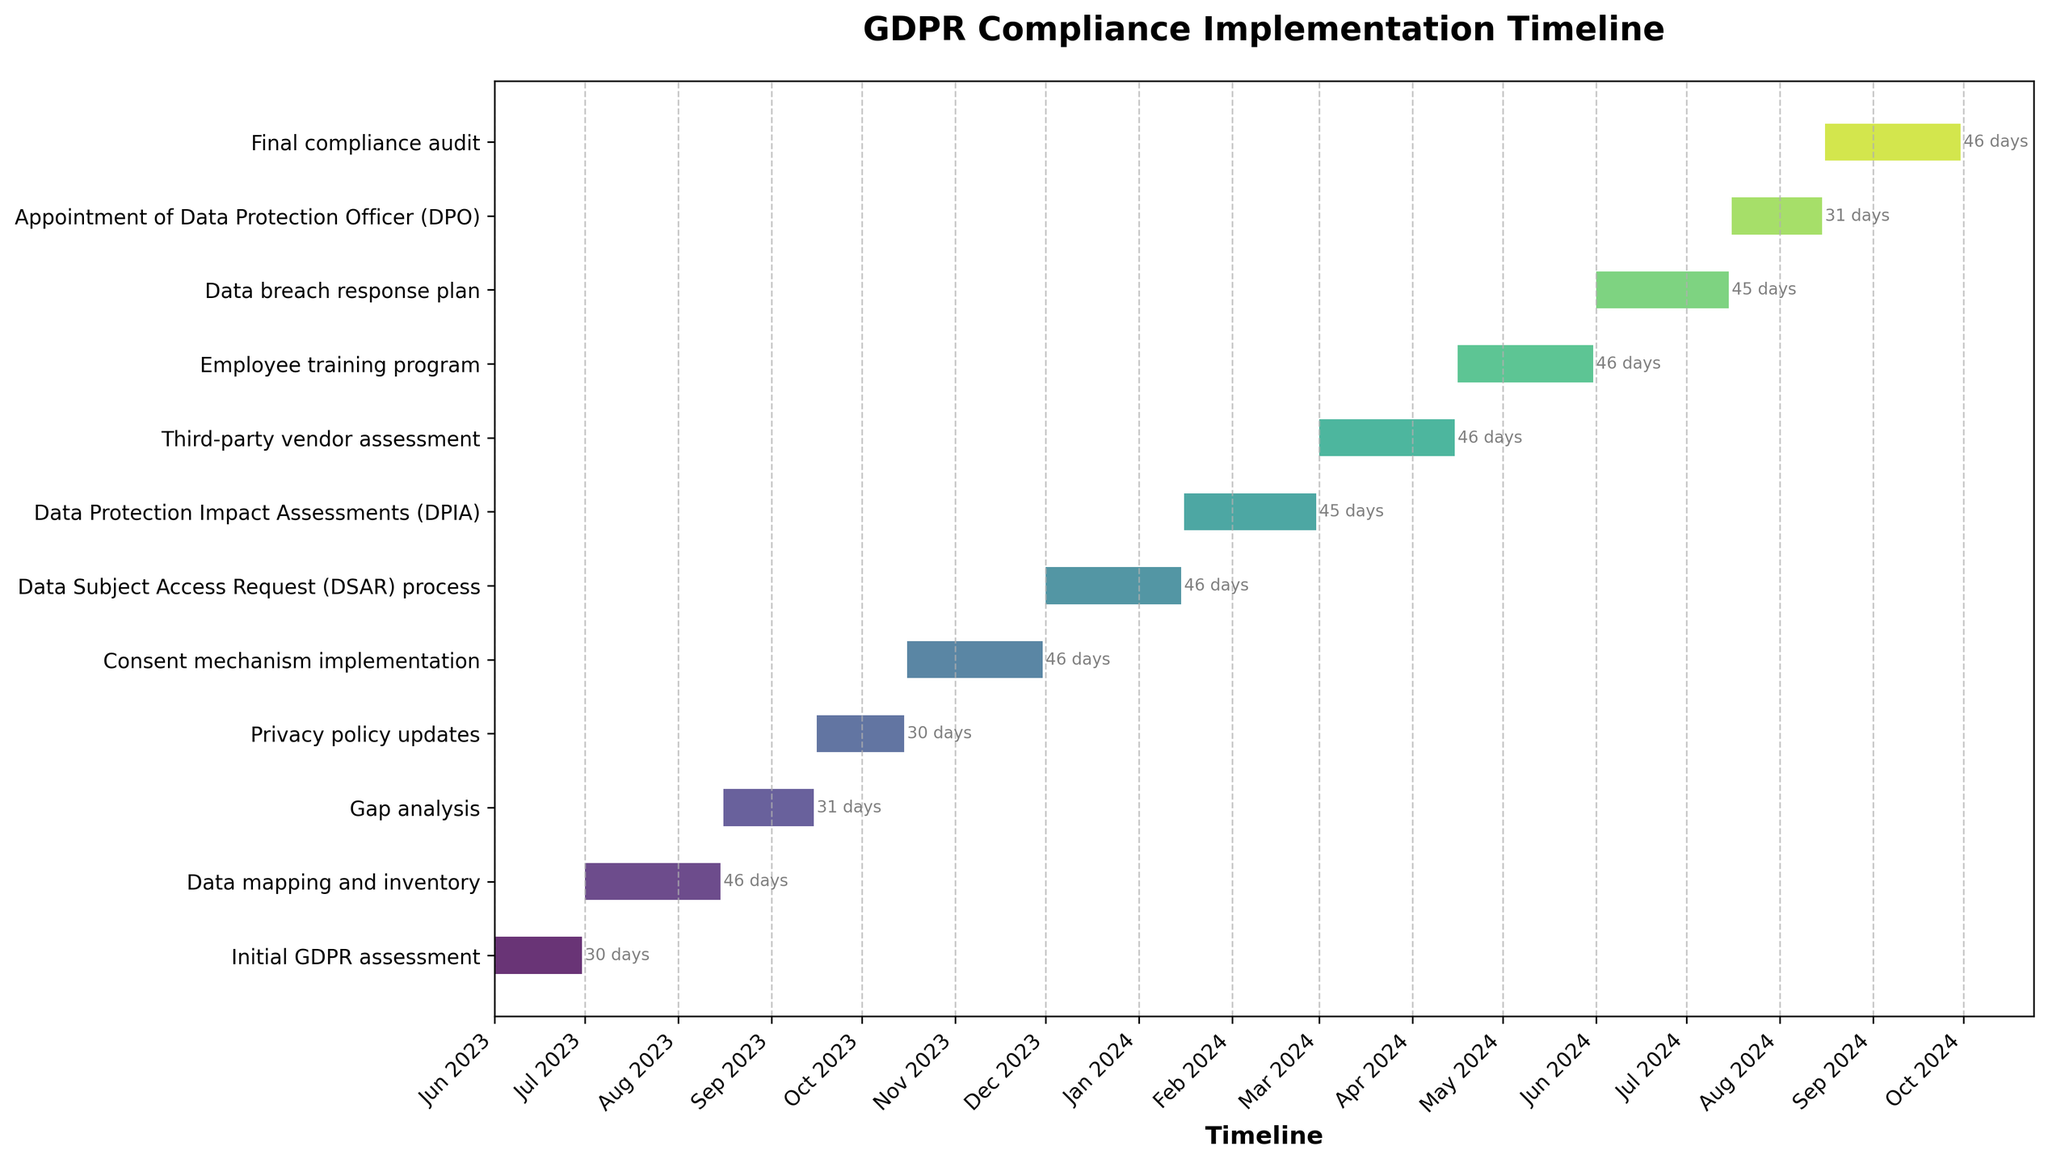What is the title of the Gantt Chart? The title is usually found at the top of the chart. In this case, it is specified as "GDPR Compliance Implementation Timeline."
Answer: GDPR Compliance Implementation Timeline How many tasks are represented in the Gantt Chart? Count the total number of tasks labeled on the y-axis of the chart. Each task represents a different component of the GDPR compliance implementation.
Answer: 12 Which task has the longest duration? Check the duration labels next to each task bar to find the one with the highest value. The "Consent mechanism implementation," "Data Subject Access Request (DSAR) process," "Third-party vendor assessment," "Employee training program," and the "Final compliance audit" tasks each have a duration of 46 days.
Answer: Five tasks are tied at 46 days each When does the "Privacy policy updates" task start and end? Look at the bar representing the "Privacy policy updates" task and read the dates on the x-axis that align with the start and end of the bar.
Answer: Starts on 2023-09-16 and ends on 2023-10-15 How long is the "Data breach response plan" task? The duration of each task is written next to the end of the task's bar on the Gantt Chart. For "Data breach response plan," it reads 45 days.
Answer: 45 days Which task begins immediately after the "Employee training program"? Identify the end date of the "Employee training program" task and look for the task that starts immediately after this date on the Gantt Chart. The "Data breach response plan" task starts immediately afterward.
Answer: Data breach response plan When does the "Final compliance audit" task start? Trace the "Final compliance audit" task to its start position on the x-axis to identify its start date.
Answer: 2024-08-16 How many tasks are scheduled to end in the year 2024? Review the end dates for all tasks and count those ending within the year 2024 to determine the number. There are six tasks: DSAR process, DPIA, Third-party vendor assessment, Employee training program, Data breach response plan, and Final compliance audit.
Answer: 6 Which task lasts longer: "Data Protection Impact Assessments (DPIA)" or "Appointment of Data Protection Officer (DPO)"? Compare the duration days indicated next to each task's bar. The "DPIA" task lasts 45 days, whereas the "DPO" appointment lasts 31 days.
Answer: Data Protection Impact Assessments (DPIA) Calculate the total time span of the entire project from the start of the first task to the end of the last task. Identify the start date of the first task (Initial GDPR assessment: 2023-06-01) and the end date of the last task (Final compliance audit: 2024-09-30). Calculate the time span between these two dates. 2023-06-01 to 2024-09-30 covers 1 year, 3 months, and 29 days, equivalent to 487 days.
Answer: 487 days 